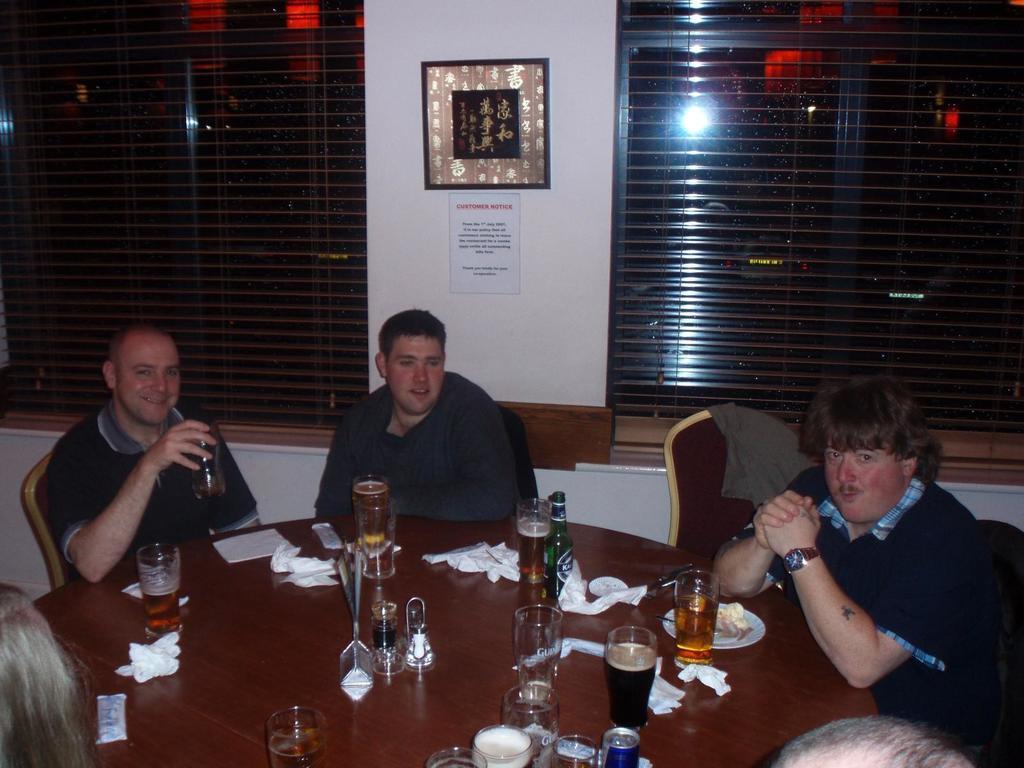Describe this image in one or two sentences. In this picture there are three men who are sitting on the chair. There is a jacket on the chair. There is a glass, paper, plate, bottle on the table. There is a frame on the wall. There is a poster on the wall. There is a light at the background. 